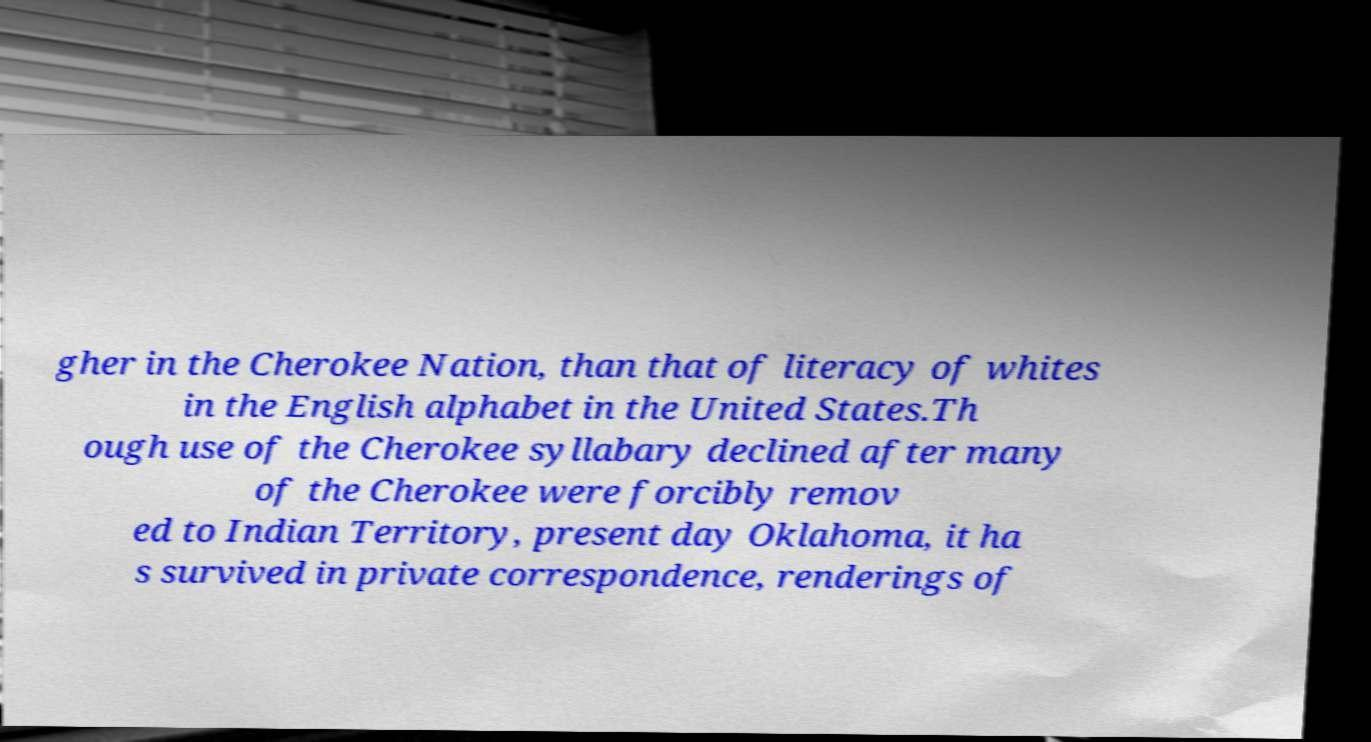Can you read and provide the text displayed in the image?This photo seems to have some interesting text. Can you extract and type it out for me? gher in the Cherokee Nation, than that of literacy of whites in the English alphabet in the United States.Th ough use of the Cherokee syllabary declined after many of the Cherokee were forcibly remov ed to Indian Territory, present day Oklahoma, it ha s survived in private correspondence, renderings of 